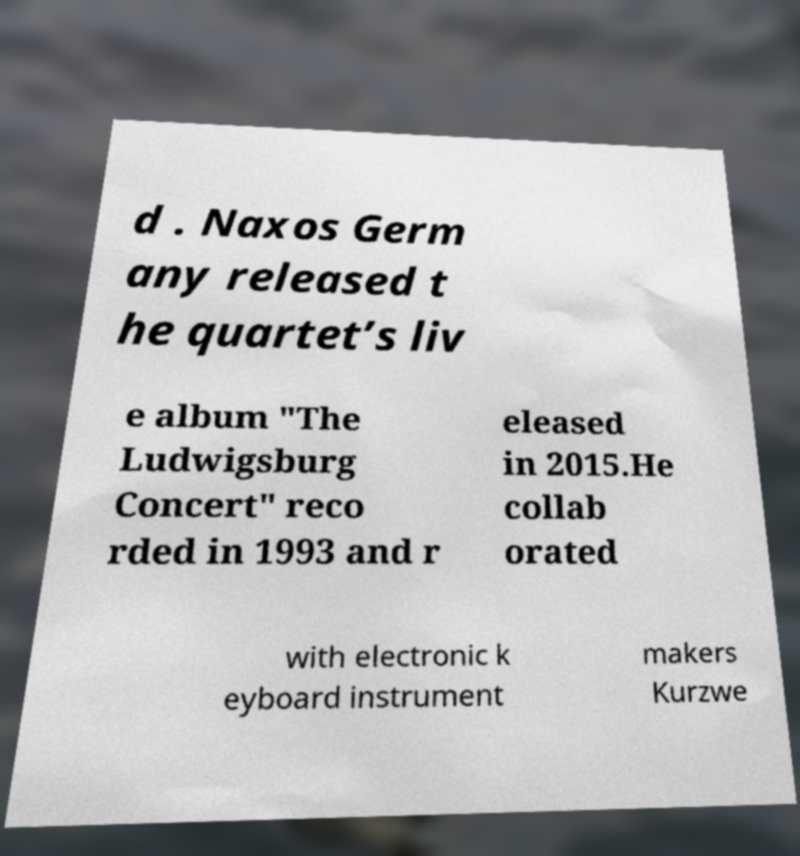For documentation purposes, I need the text within this image transcribed. Could you provide that? d . Naxos Germ any released t he quartet’s liv e album "The Ludwigsburg Concert" reco rded in 1993 and r eleased in 2015.He collab orated with electronic k eyboard instrument makers Kurzwe 